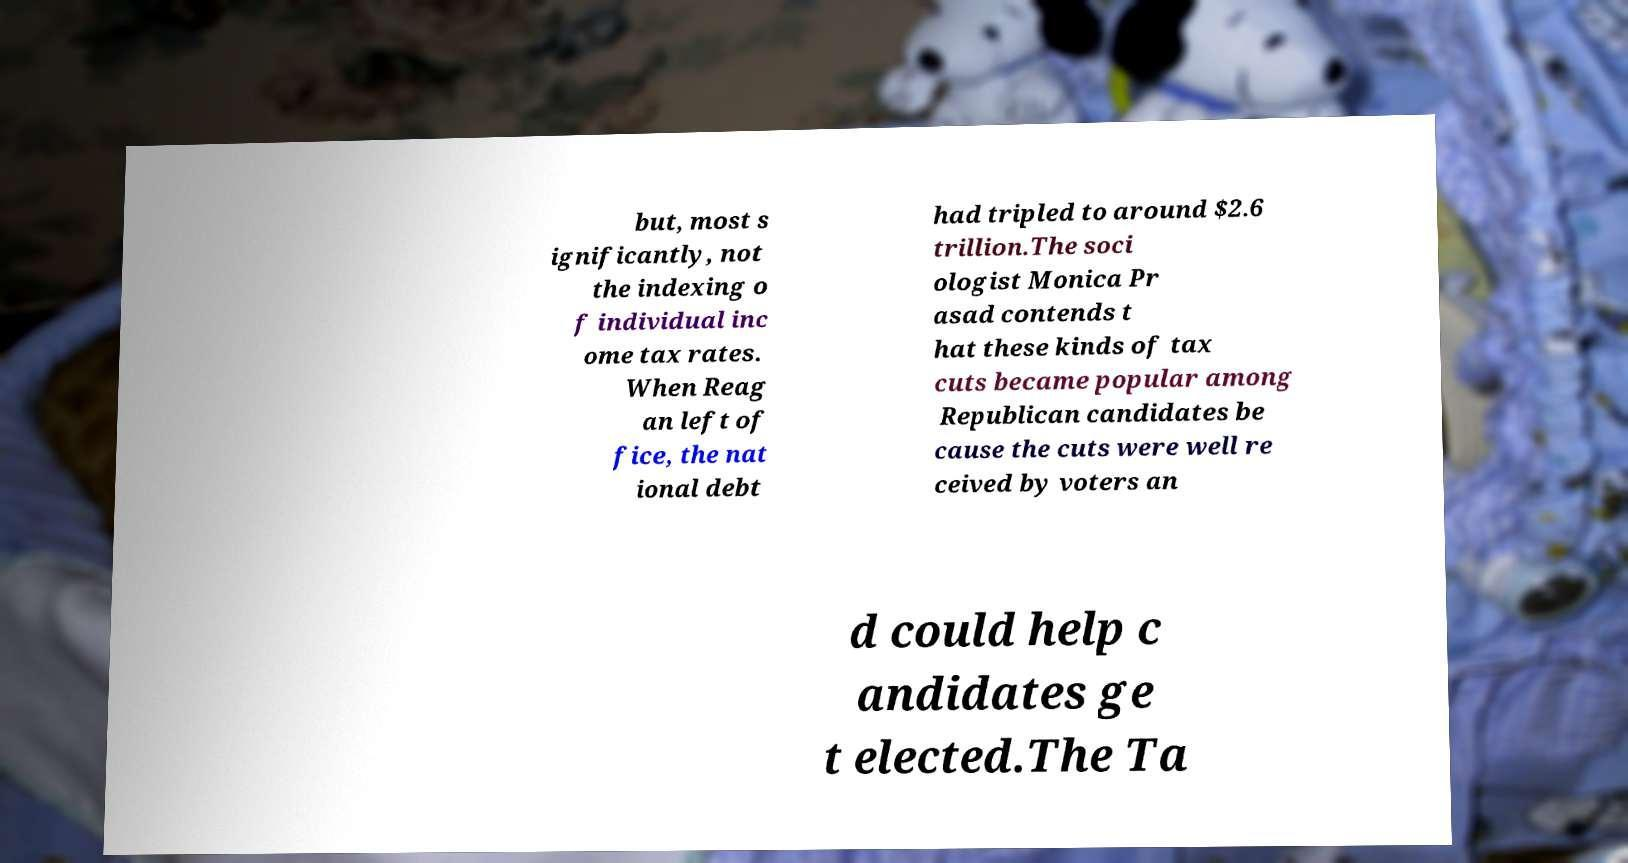What messages or text are displayed in this image? I need them in a readable, typed format. but, most s ignificantly, not the indexing o f individual inc ome tax rates. When Reag an left of fice, the nat ional debt had tripled to around $2.6 trillion.The soci ologist Monica Pr asad contends t hat these kinds of tax cuts became popular among Republican candidates be cause the cuts were well re ceived by voters an d could help c andidates ge t elected.The Ta 